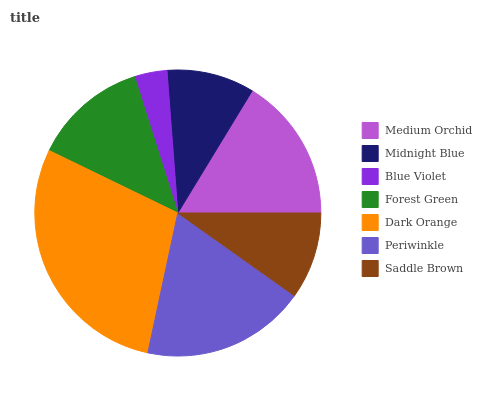Is Blue Violet the minimum?
Answer yes or no. Yes. Is Dark Orange the maximum?
Answer yes or no. Yes. Is Midnight Blue the minimum?
Answer yes or no. No. Is Midnight Blue the maximum?
Answer yes or no. No. Is Medium Orchid greater than Midnight Blue?
Answer yes or no. Yes. Is Midnight Blue less than Medium Orchid?
Answer yes or no. Yes. Is Midnight Blue greater than Medium Orchid?
Answer yes or no. No. Is Medium Orchid less than Midnight Blue?
Answer yes or no. No. Is Forest Green the high median?
Answer yes or no. Yes. Is Forest Green the low median?
Answer yes or no. Yes. Is Periwinkle the high median?
Answer yes or no. No. Is Saddle Brown the low median?
Answer yes or no. No. 